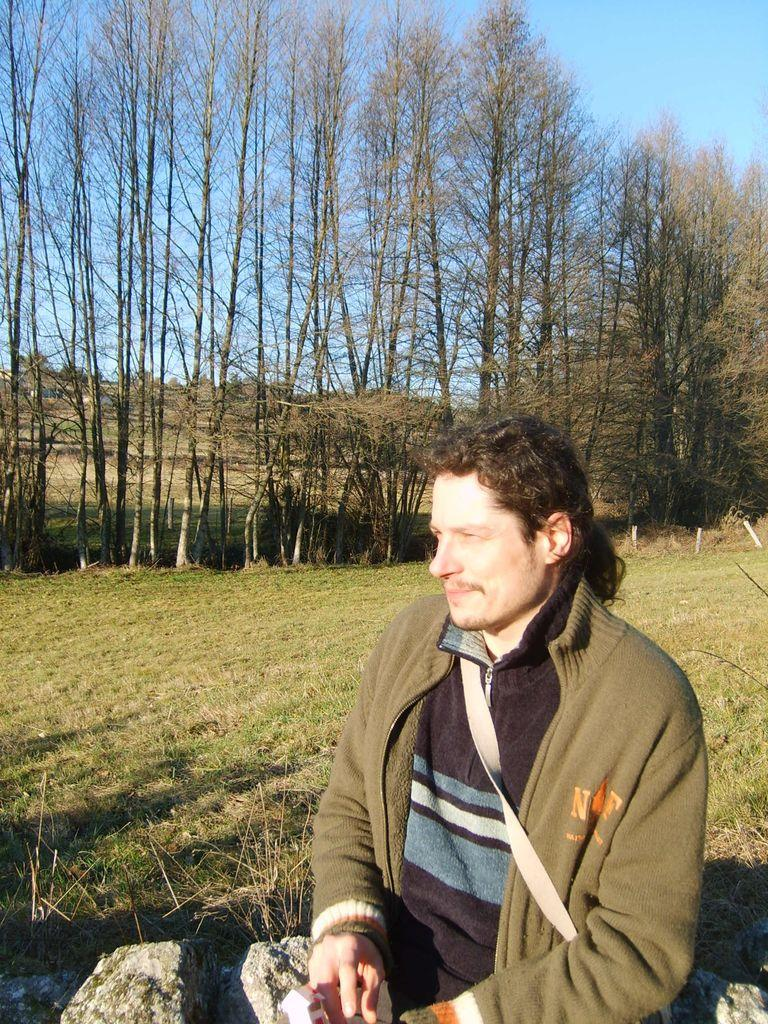Who is the main subject in the image? There is a man in the image. What type of natural environment is visible behind the man? There is a lot of grass behind the man. What can be seen beyond the grass in the image? There are many tall trees behind the grass. How many sisters does the man have in the image? There is no information about the man's sisters in the image, so we cannot determine the number of sisters he has. 